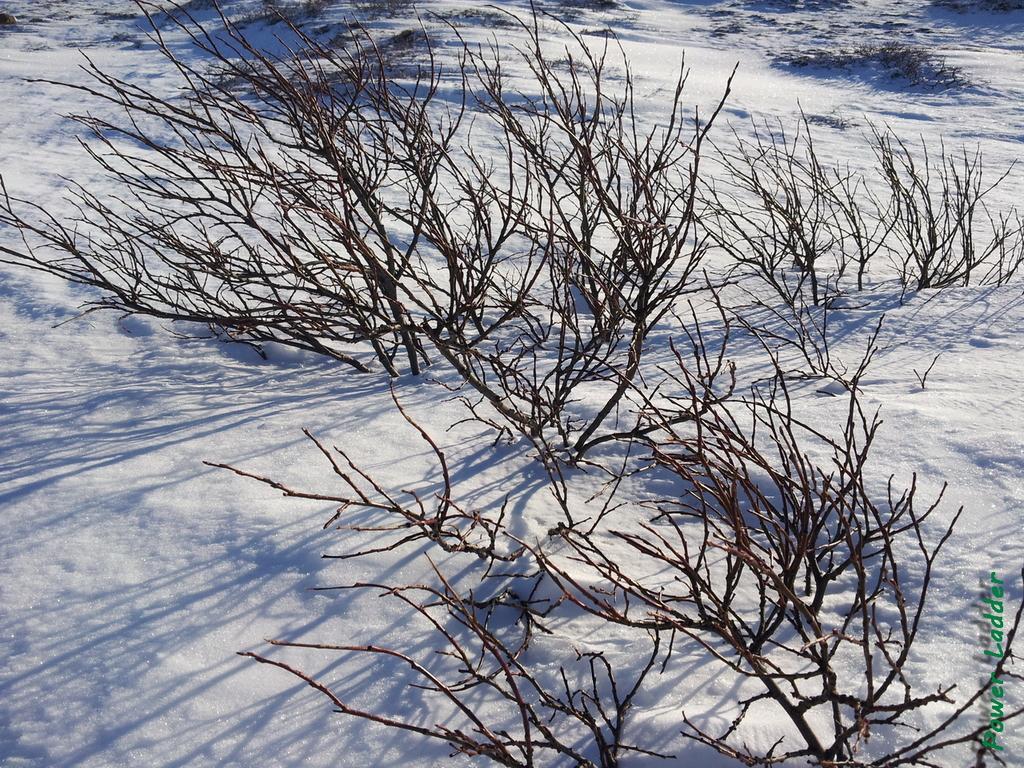Describe this image in one or two sentences. This is snow and there are bare trees. 